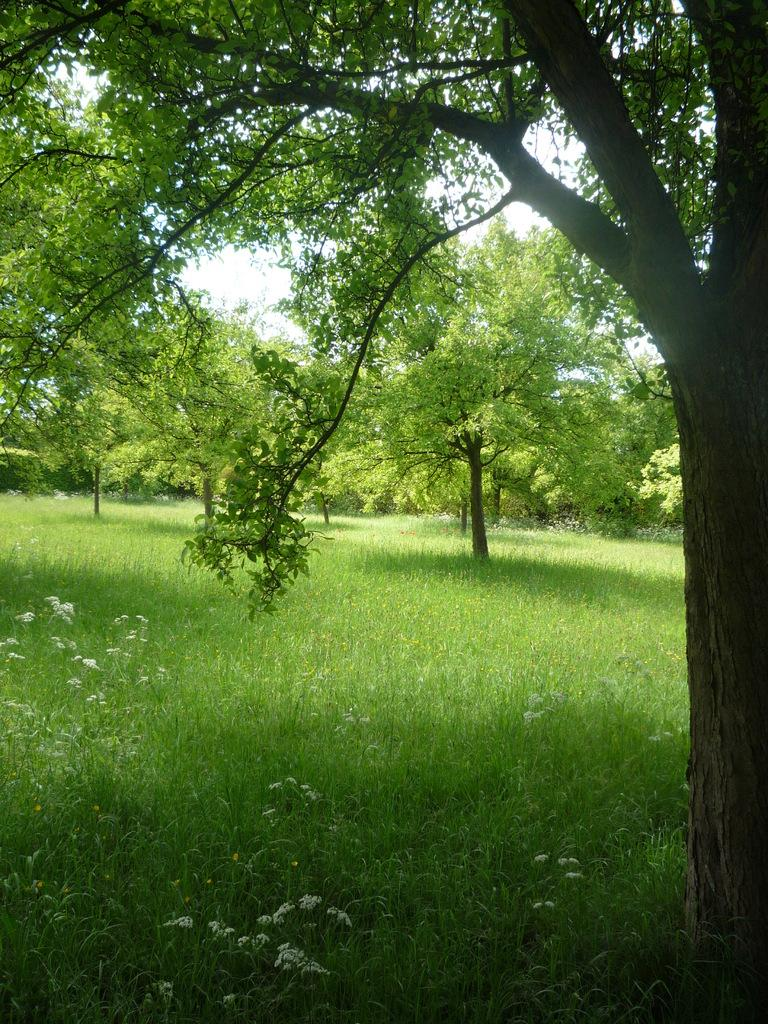What type of vegetation is present in the image? There is green grass in the image. What other natural elements can be seen in the image? There are trees in the image. What is visible in the background of the image? The sky is visible in the background of the image. What type of treatment is being administered to the trees in the image? There is no treatment being administered to the trees in the image; they are simply standing in the background. Is there a tent visible in the image? No, there is no tent present in the image. 